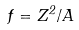Convert formula to latex. <formula><loc_0><loc_0><loc_500><loc_500>f = Z ^ { 2 } / A</formula> 